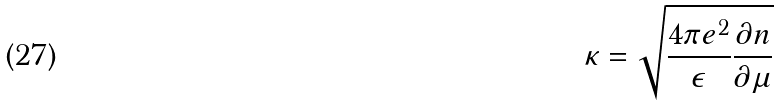<formula> <loc_0><loc_0><loc_500><loc_500>\kappa = \sqrt { \frac { 4 \pi e ^ { 2 } } { \epsilon } \frac { \partial n } { \partial \mu } }</formula> 